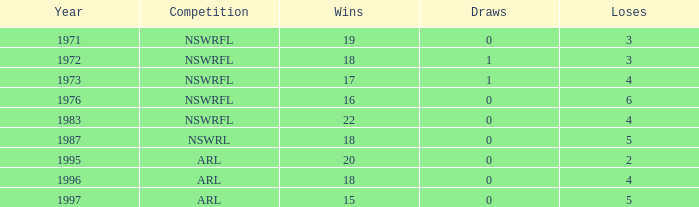What average Wins has Losses 2, and Draws less than 0? None. Could you parse the entire table? {'header': ['Year', 'Competition', 'Wins', 'Draws', 'Loses'], 'rows': [['1971', 'NSWRFL', '19', '0', '3'], ['1972', 'NSWRFL', '18', '1', '3'], ['1973', 'NSWRFL', '17', '1', '4'], ['1976', 'NSWRFL', '16', '0', '6'], ['1983', 'NSWRFL', '22', '0', '4'], ['1987', 'NSWRL', '18', '0', '5'], ['1995', 'ARL', '20', '0', '2'], ['1996', 'ARL', '18', '0', '4'], ['1997', 'ARL', '15', '0', '5']]} 